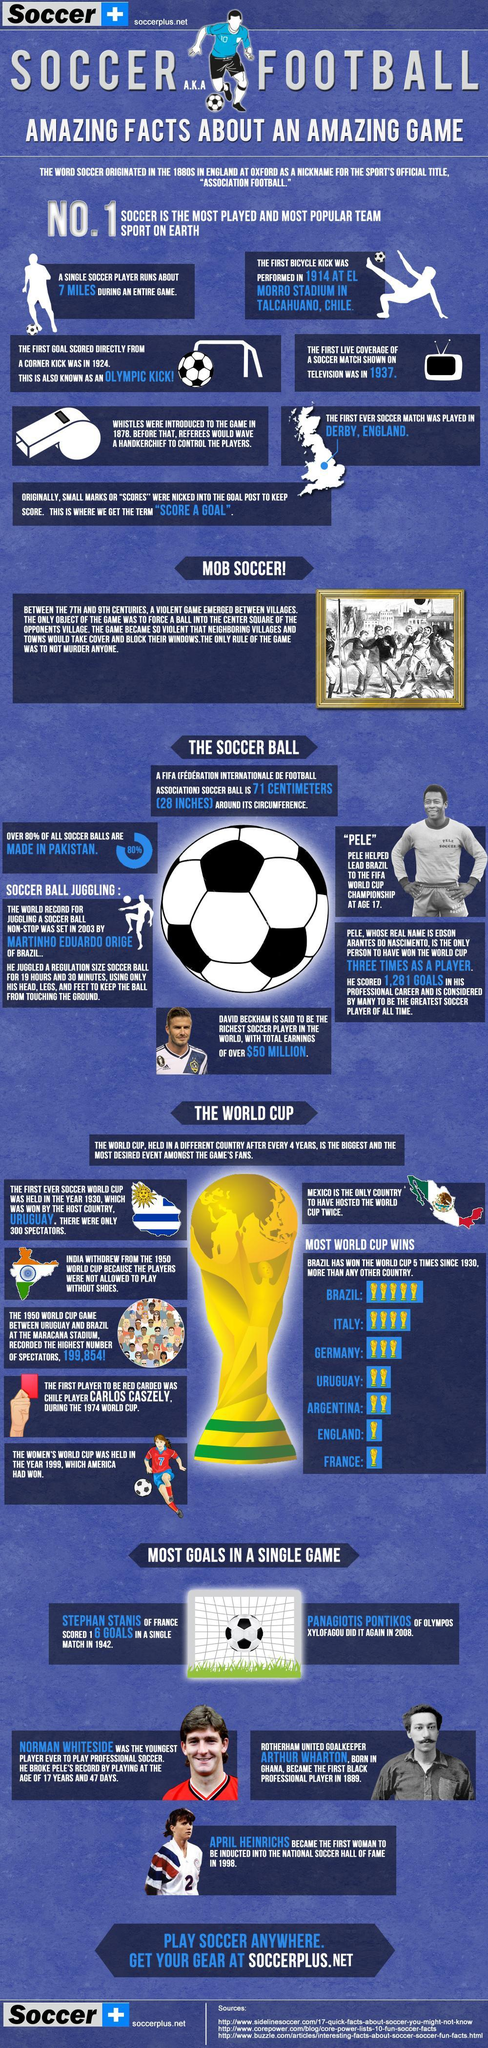Which country did the first black professional soccer player hale from?
Answer the question with a short phrase. Ghana At What age did Edson Arantes Do Nascimento lead Brazil to FIFA World Cup Championship? 17 When was the first Olympic kick scored? 1924 Which country hosted the world cup two times? Mexico Which countries have won the world cup twice? Uruguay,Argentina Where was the first ever soccer world cup held in the year 1930? Uruguay How many times did Italy win the world cup? 4 From When did a soccer match started being shown live? 1937 Which countries have won the world cup once? England,France Which country makes the majority of soccer balls? Pakistan 